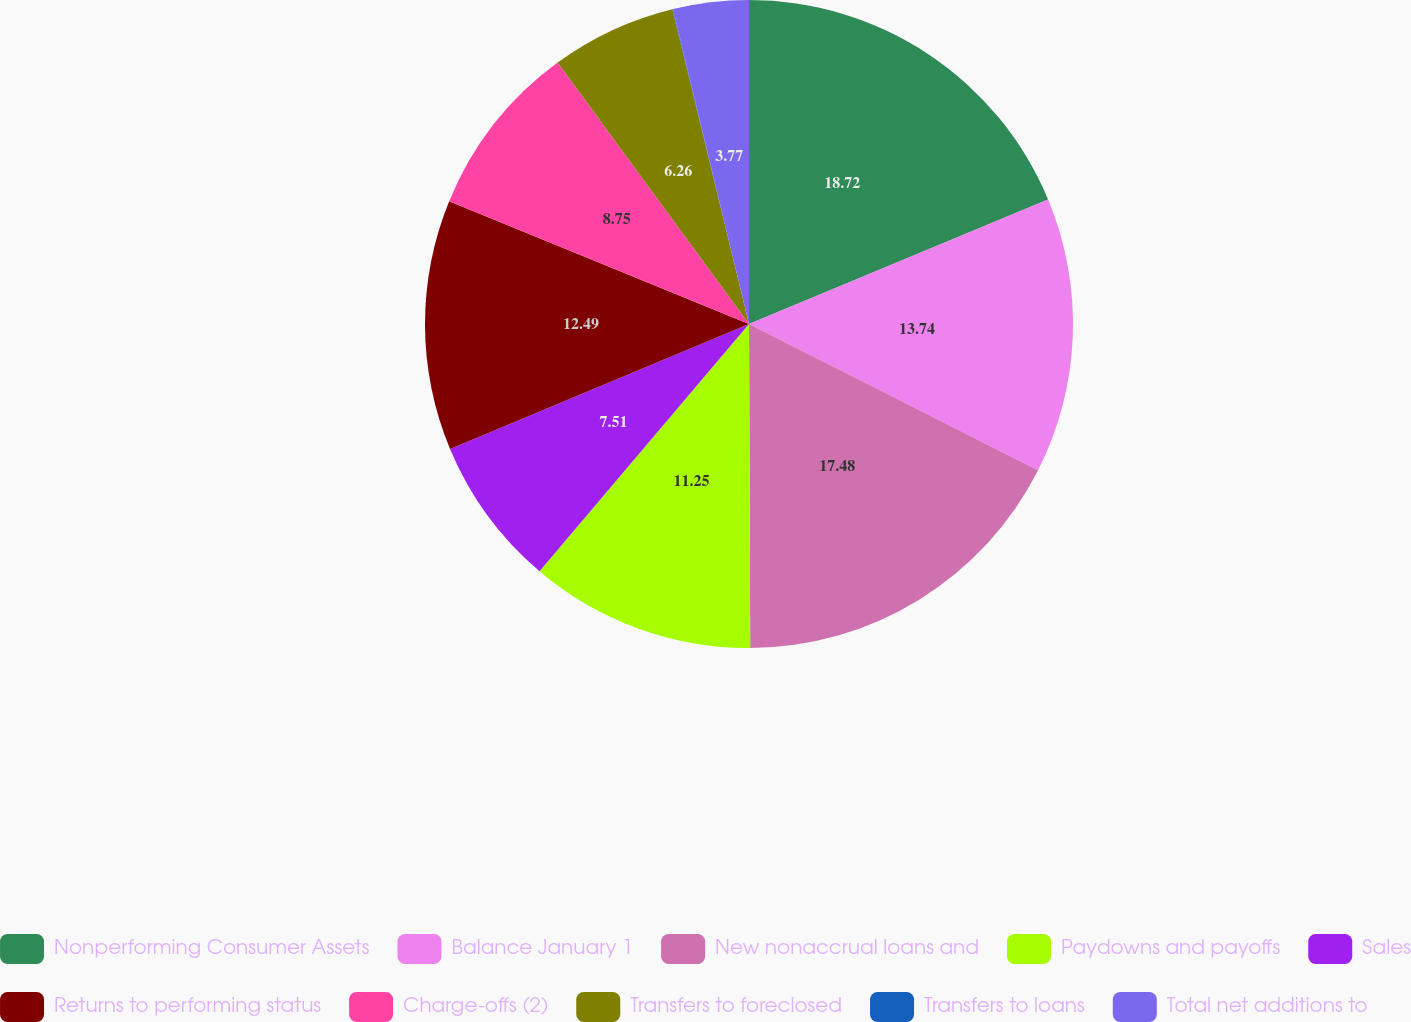<chart> <loc_0><loc_0><loc_500><loc_500><pie_chart><fcel>Nonperforming Consumer Assets<fcel>Balance January 1<fcel>New nonaccrual loans and<fcel>Paydowns and payoffs<fcel>Sales<fcel>Returns to performing status<fcel>Charge-offs (2)<fcel>Transfers to foreclosed<fcel>Transfers to loans<fcel>Total net additions to<nl><fcel>18.72%<fcel>13.74%<fcel>17.48%<fcel>11.25%<fcel>7.51%<fcel>12.49%<fcel>8.75%<fcel>6.26%<fcel>0.03%<fcel>3.77%<nl></chart> 